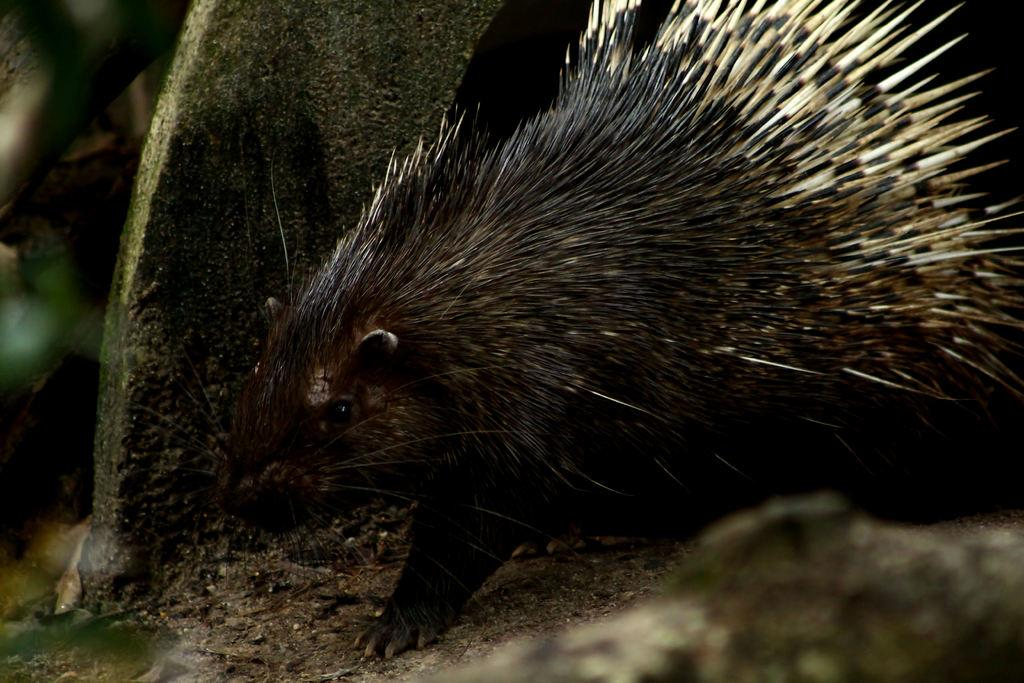What type of animal can be seen in the image? There is an animal in the image that resembles a porcupine. What is present at the bottom of the image? There are stones and twigs at the bottom of the image. What structure is visible in the image? There is a wall visible in the image. How would you describe the background of the image? The background of the image is blurred. How does the animal react to the fear of the rainstorm in the image? There is no rainstorm present in the image, and therefore no fear or reaction to it can be observed. What type of goat is visible in the image? There is no goat present in the image; it features an animal that resembles a porcupine. 